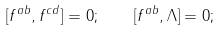<formula> <loc_0><loc_0><loc_500><loc_500>[ f ^ { a b } , f ^ { c d } ] = 0 ; \quad [ f ^ { a b } , \Lambda ] = 0 ;</formula> 